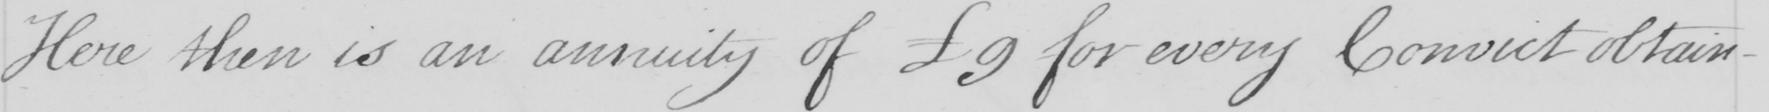Please transcribe the handwritten text in this image. Here then is an annuity of 9 for every Convict obtain- 